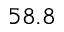<formula> <loc_0><loc_0><loc_500><loc_500>5 8 . 8</formula> 